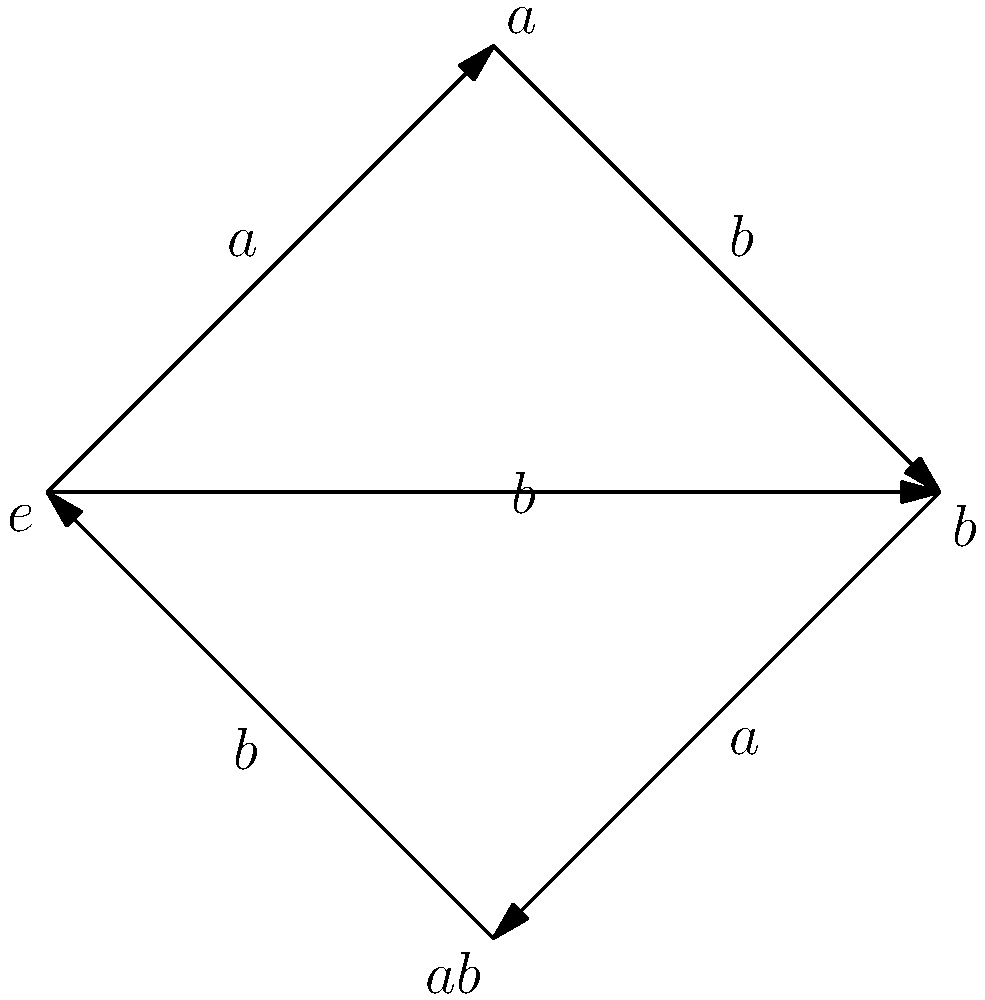Given the Cayley graph of a group $G$ with presentation $\langle a,b \mid a^2=b^2=(ab)^2=e \rangle$, determine the order of the group and identify its isomorphism class. How does this graph demonstrate the efficiency of Cayley graphs in representing group structure compared to other methods? 1. Analyze the vertices:
   - The graph has 4 vertices: $e$ (identity), $a$, $b$, and $ab$.
   - This indicates that $|G| = 4$.

2. Verify the group relations:
   - $a^2 = e$: Following the $a$ edge twice returns to $e$.
   - $b^2 = e$: Following the $b$ edge twice returns to $e$.
   - $(ab)^2 = e$: Following $a$ then $b$ twice returns to $e$.

3. Identify the group:
   - The only group of order 4 with these properties is the Klein four-group, $V_4$.
   - $V_4 \cong \mathbb{Z}_2 \times \mathbb{Z}_2$.

4. Efficiency of Cayley graphs:
   - Compact representation: All group elements and their relationships are shown in one diagram.
   - Visual symmetry: The graph's symmetry reflects the group's algebraic structure.
   - Easy to verify relations: Group axioms and specific relations can be quickly checked by following paths.
   - Intuitive for composition: Multiplying elements is equivalent to following edges.
   - Facilitates subgroup identification: Subgroups appear as symmetric subgraphs.

5. Comparison to other methods:
   - More intuitive than abstract algebraic notation.
   - More compact than Cayley tables for larger groups.
   - Provides immediate visual insight into group structure and symmetries.
Answer: Order: 4; Isomorphic to $V_4 \cong \mathbb{Z}_2 \times \mathbb{Z}_2$; Cayley graphs efficiently represent elements, relations, and structure visually. 